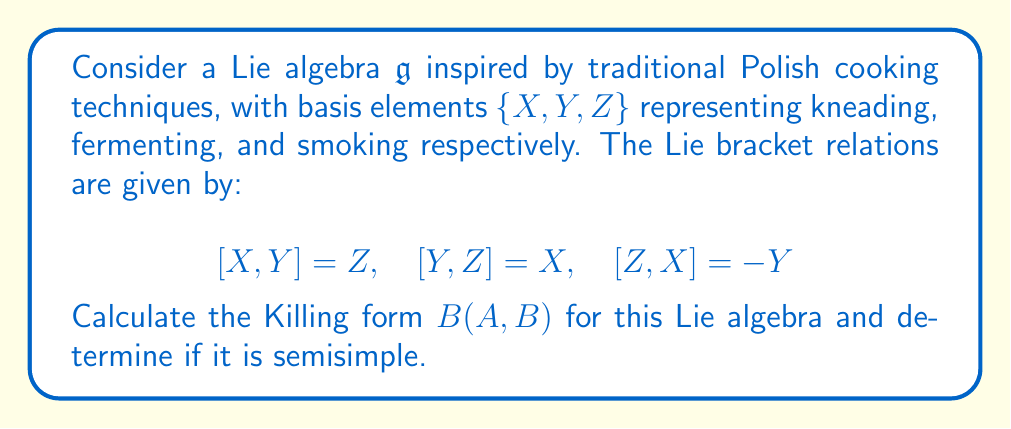Provide a solution to this math problem. To calculate the Killing form and determine if the Lie algebra is semisimple, we'll follow these steps:

1) The Killing form is defined as $B(A,B) = \text{tr}(\text{ad}(A) \circ \text{ad}(B))$, where $\text{ad}(A)$ is the adjoint representation of $A$.

2) First, let's calculate the adjoint representations for each basis element:

   For $X$: $\text{ad}(X)(Y) = [X,Y] = Z$, $\text{ad}(X)(Z) = [X,Z] = Y$
   $$\text{ad}(X) = \begin{pmatrix} 0 & 0 & 0 \\ 0 & 0 & -1 \\ 0 & 1 & 0 \end{pmatrix}$$

   For $Y$: $\text{ad}(Y)(Z) = [Y,Z] = X$, $\text{ad}(Y)(X) = [Y,X] = -Z$
   $$\text{ad}(Y) = \begin{pmatrix} 0 & 0 & 1 \\ 0 & 0 & 0 \\ -1 & 0 & 0 \end{pmatrix}$$

   For $Z$: $\text{ad}(Z)(X) = [Z,X] = -Y$, $\text{ad}(Z)(Y) = [Z,Y] = -X$
   $$\text{ad}(Z) = \begin{pmatrix} 0 & -1 & 0 \\ 1 & 0 & 0 \\ 0 & 0 & 0 \end{pmatrix}$$

3) Now, let's calculate $B(X,X)$, $B(Y,Y)$, and $B(Z,Z)$:

   $B(X,X) = \text{tr}(\text{ad}(X) \circ \text{ad}(X)) = \text{tr}\begin{pmatrix} 0 & 0 & 0 \\ 0 & -1 & 0 \\ 0 & 0 & -1 \end{pmatrix} = -2$

   $B(Y,Y) = \text{tr}(\text{ad}(Y) \circ \text{ad}(Y)) = \text{tr}\begin{pmatrix} -1 & 0 & 0 \\ 0 & 0 & 0 \\ 0 & 0 & -1 \end{pmatrix} = -2$

   $B(Z,Z) = \text{tr}(\text{ad}(Z) \circ \text{ad}(Z)) = \text{tr}\begin{pmatrix} -1 & 0 & 0 \\ 0 & -1 & 0 \\ 0 & 0 & 0 \end{pmatrix} = -2$

4) For the off-diagonal elements, we can see that $B(X,Y) = B(Y,Z) = B(Z,X) = 0$ due to the structure of the adjoint matrices.

5) Therefore, the Killing form matrix is:

   $$B = \begin{pmatrix} -2 & 0 & 0 \\ 0 & -2 & 0 \\ 0 & 0 & -2 \end{pmatrix}$$

6) A Lie algebra is semisimple if and only if its Killing form is non-degenerate (i.e., has non-zero determinant).

7) The determinant of $B$ is $(-2)^3 = -8 \neq 0$, so the Killing form is non-degenerate.

Therefore, this Lie algebra inspired by Polish cooking techniques is semisimple.
Answer: The Killing form for the given Lie algebra is:

$$B = \begin{pmatrix} -2 & 0 & 0 \\ 0 & -2 & 0 \\ 0 & 0 & -2 \end{pmatrix}$$

The Lie algebra is semisimple because the Killing form is non-degenerate. 